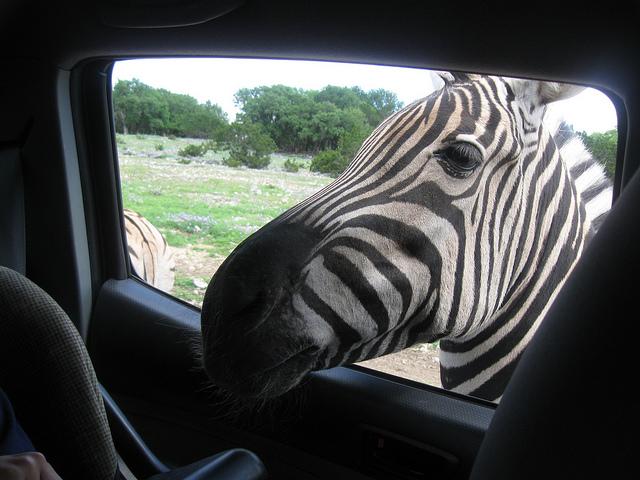How many zebras are there?
Keep it brief. 2. What position is the window in?
Answer briefly. Down. How many animals are there near the vehicle that can be seen?
Write a very short answer. 2. What animal has its head in the window?
Answer briefly. Zebra. 